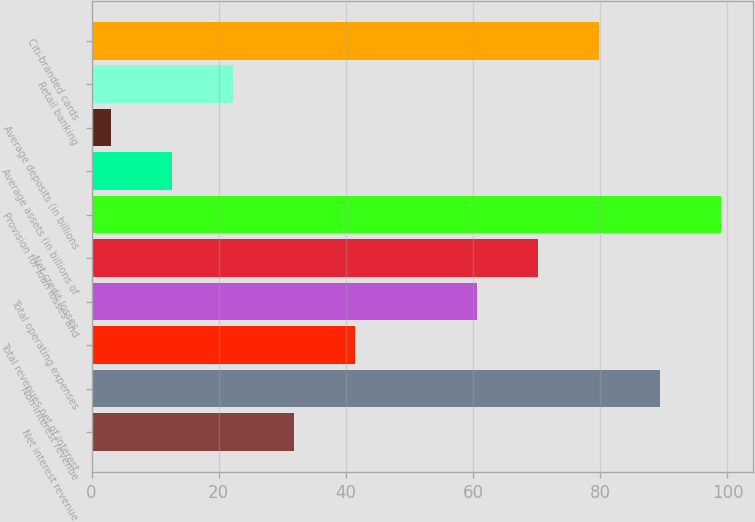Convert chart to OTSL. <chart><loc_0><loc_0><loc_500><loc_500><bar_chart><fcel>Net interest revenue<fcel>Non-interest revenue<fcel>Total revenues net of interest<fcel>Total operating expenses<fcel>Net credit losses<fcel>Provision for loan losses and<fcel>Average assets (in billions of<fcel>Average deposits (in billions<fcel>Retail banking<fcel>Citi-branded cards<nl><fcel>31.8<fcel>89.4<fcel>41.4<fcel>60.6<fcel>70.2<fcel>99<fcel>12.6<fcel>3<fcel>22.2<fcel>79.8<nl></chart> 